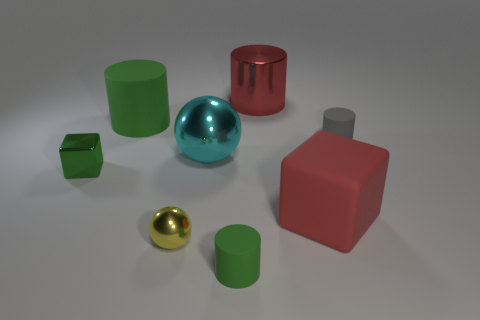Subtract all tiny gray cylinders. How many cylinders are left? 3 Subtract all cubes. How many objects are left? 6 Add 1 small gray metallic objects. How many objects exist? 9 Subtract 2 cubes. How many cubes are left? 0 Subtract all gray cylinders. How many cylinders are left? 3 Subtract 0 brown spheres. How many objects are left? 8 Subtract all red cubes. Subtract all green cylinders. How many cubes are left? 1 Subtract all brown balls. How many red cylinders are left? 1 Subtract all balls. Subtract all red things. How many objects are left? 4 Add 4 tiny cylinders. How many tiny cylinders are left? 6 